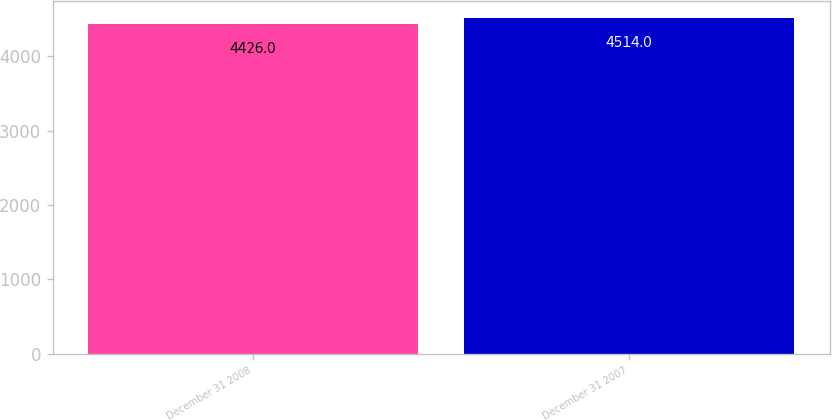<chart> <loc_0><loc_0><loc_500><loc_500><bar_chart><fcel>December 31 2008<fcel>December 31 2007<nl><fcel>4426<fcel>4514<nl></chart> 